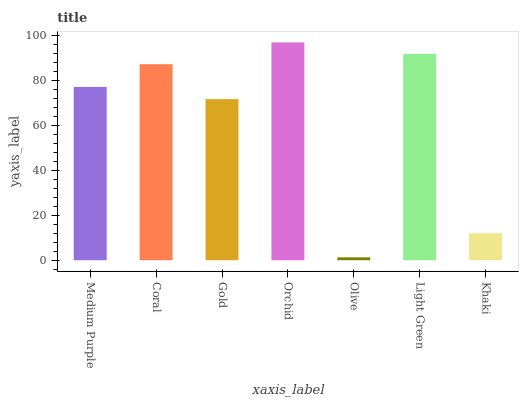Is Olive the minimum?
Answer yes or no. Yes. Is Orchid the maximum?
Answer yes or no. Yes. Is Coral the minimum?
Answer yes or no. No. Is Coral the maximum?
Answer yes or no. No. Is Coral greater than Medium Purple?
Answer yes or no. Yes. Is Medium Purple less than Coral?
Answer yes or no. Yes. Is Medium Purple greater than Coral?
Answer yes or no. No. Is Coral less than Medium Purple?
Answer yes or no. No. Is Medium Purple the high median?
Answer yes or no. Yes. Is Medium Purple the low median?
Answer yes or no. Yes. Is Orchid the high median?
Answer yes or no. No. Is Gold the low median?
Answer yes or no. No. 